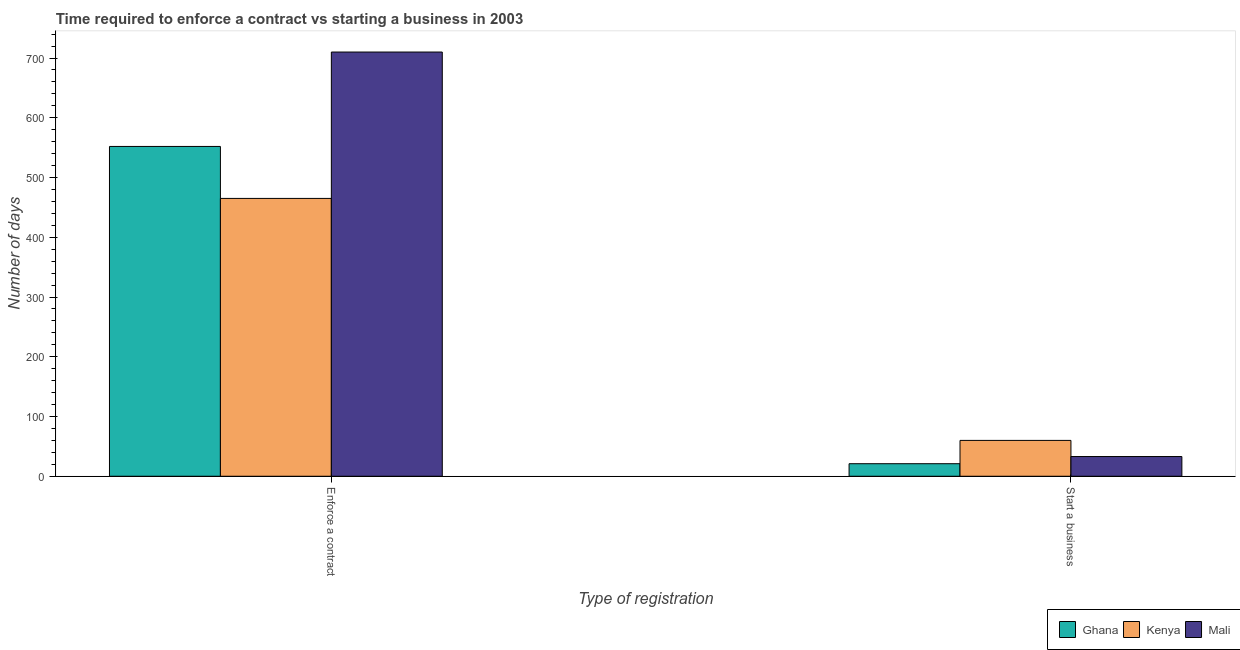How many groups of bars are there?
Provide a succinct answer. 2. Are the number of bars per tick equal to the number of legend labels?
Make the answer very short. Yes. Are the number of bars on each tick of the X-axis equal?
Your answer should be very brief. Yes. What is the label of the 1st group of bars from the left?
Ensure brevity in your answer.  Enforce a contract. What is the number of days to start a business in Kenya?
Offer a terse response. 60. Across all countries, what is the maximum number of days to start a business?
Ensure brevity in your answer.  60. Across all countries, what is the minimum number of days to enforece a contract?
Your answer should be very brief. 465. In which country was the number of days to start a business maximum?
Your response must be concise. Kenya. In which country was the number of days to enforece a contract minimum?
Your answer should be compact. Kenya. What is the total number of days to enforece a contract in the graph?
Provide a short and direct response. 1727. What is the difference between the number of days to start a business in Mali and that in Kenya?
Provide a short and direct response. -27. What is the difference between the number of days to start a business in Kenya and the number of days to enforece a contract in Ghana?
Keep it short and to the point. -492. What is the average number of days to enforece a contract per country?
Keep it short and to the point. 575.67. What is the difference between the number of days to enforece a contract and number of days to start a business in Kenya?
Give a very brief answer. 405. In how many countries, is the number of days to enforece a contract greater than 20 days?
Give a very brief answer. 3. What is the ratio of the number of days to start a business in Mali to that in Ghana?
Offer a very short reply. 1.57. Is the number of days to enforece a contract in Mali less than that in Ghana?
Ensure brevity in your answer.  No. In how many countries, is the number of days to enforece a contract greater than the average number of days to enforece a contract taken over all countries?
Your answer should be very brief. 1. What does the 1st bar from the left in Enforce a contract represents?
Offer a very short reply. Ghana. What does the 3rd bar from the right in Start a business represents?
Your answer should be compact. Ghana. Are all the bars in the graph horizontal?
Your answer should be very brief. No. Does the graph contain any zero values?
Make the answer very short. No. Does the graph contain grids?
Your response must be concise. No. How are the legend labels stacked?
Ensure brevity in your answer.  Horizontal. What is the title of the graph?
Make the answer very short. Time required to enforce a contract vs starting a business in 2003. Does "Guinea" appear as one of the legend labels in the graph?
Provide a short and direct response. No. What is the label or title of the X-axis?
Offer a terse response. Type of registration. What is the label or title of the Y-axis?
Your response must be concise. Number of days. What is the Number of days in Ghana in Enforce a contract?
Provide a short and direct response. 552. What is the Number of days in Kenya in Enforce a contract?
Offer a very short reply. 465. What is the Number of days of Mali in Enforce a contract?
Your answer should be very brief. 710. What is the Number of days in Ghana in Start a business?
Ensure brevity in your answer.  21. Across all Type of registration, what is the maximum Number of days in Ghana?
Provide a succinct answer. 552. Across all Type of registration, what is the maximum Number of days in Kenya?
Your answer should be compact. 465. Across all Type of registration, what is the maximum Number of days of Mali?
Offer a terse response. 710. Across all Type of registration, what is the minimum Number of days of Ghana?
Your answer should be compact. 21. Across all Type of registration, what is the minimum Number of days of Mali?
Ensure brevity in your answer.  33. What is the total Number of days of Ghana in the graph?
Offer a terse response. 573. What is the total Number of days of Kenya in the graph?
Keep it short and to the point. 525. What is the total Number of days of Mali in the graph?
Give a very brief answer. 743. What is the difference between the Number of days of Ghana in Enforce a contract and that in Start a business?
Provide a short and direct response. 531. What is the difference between the Number of days of Kenya in Enforce a contract and that in Start a business?
Offer a terse response. 405. What is the difference between the Number of days in Mali in Enforce a contract and that in Start a business?
Your response must be concise. 677. What is the difference between the Number of days in Ghana in Enforce a contract and the Number of days in Kenya in Start a business?
Keep it short and to the point. 492. What is the difference between the Number of days of Ghana in Enforce a contract and the Number of days of Mali in Start a business?
Your answer should be very brief. 519. What is the difference between the Number of days of Kenya in Enforce a contract and the Number of days of Mali in Start a business?
Give a very brief answer. 432. What is the average Number of days of Ghana per Type of registration?
Make the answer very short. 286.5. What is the average Number of days of Kenya per Type of registration?
Offer a terse response. 262.5. What is the average Number of days of Mali per Type of registration?
Offer a terse response. 371.5. What is the difference between the Number of days of Ghana and Number of days of Mali in Enforce a contract?
Your answer should be compact. -158. What is the difference between the Number of days in Kenya and Number of days in Mali in Enforce a contract?
Make the answer very short. -245. What is the difference between the Number of days in Ghana and Number of days in Kenya in Start a business?
Offer a very short reply. -39. What is the ratio of the Number of days of Ghana in Enforce a contract to that in Start a business?
Offer a terse response. 26.29. What is the ratio of the Number of days of Kenya in Enforce a contract to that in Start a business?
Keep it short and to the point. 7.75. What is the ratio of the Number of days of Mali in Enforce a contract to that in Start a business?
Provide a short and direct response. 21.52. What is the difference between the highest and the second highest Number of days of Ghana?
Your answer should be compact. 531. What is the difference between the highest and the second highest Number of days in Kenya?
Your answer should be very brief. 405. What is the difference between the highest and the second highest Number of days of Mali?
Keep it short and to the point. 677. What is the difference between the highest and the lowest Number of days of Ghana?
Make the answer very short. 531. What is the difference between the highest and the lowest Number of days in Kenya?
Your answer should be very brief. 405. What is the difference between the highest and the lowest Number of days of Mali?
Offer a terse response. 677. 